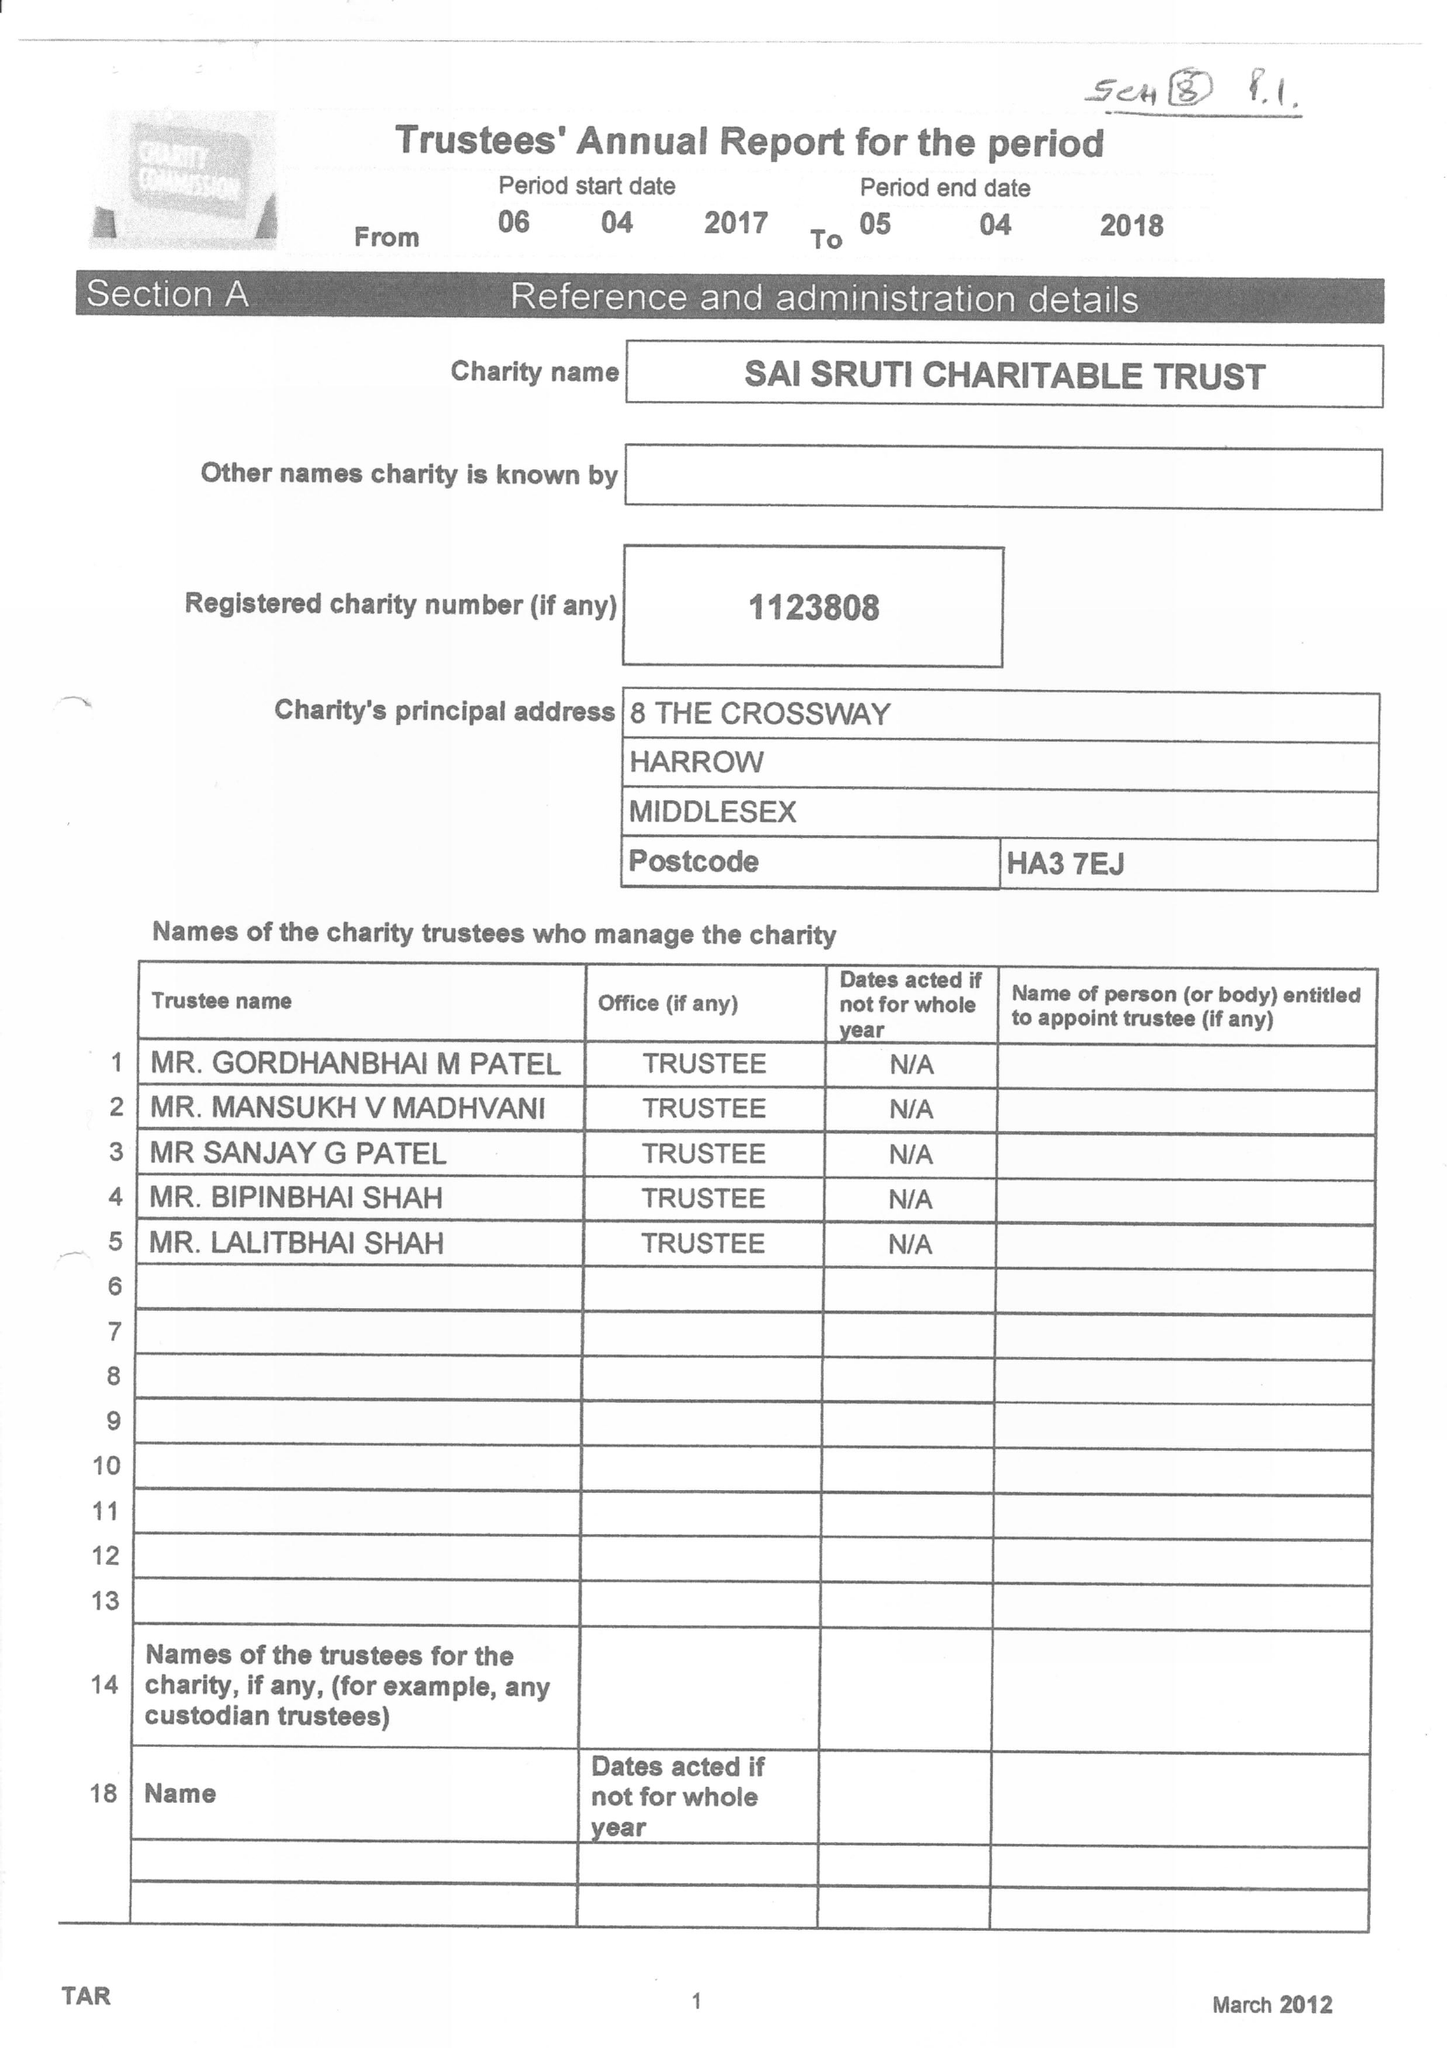What is the value for the charity_name?
Answer the question using a single word or phrase. Sai Sruti Charitable Trust 